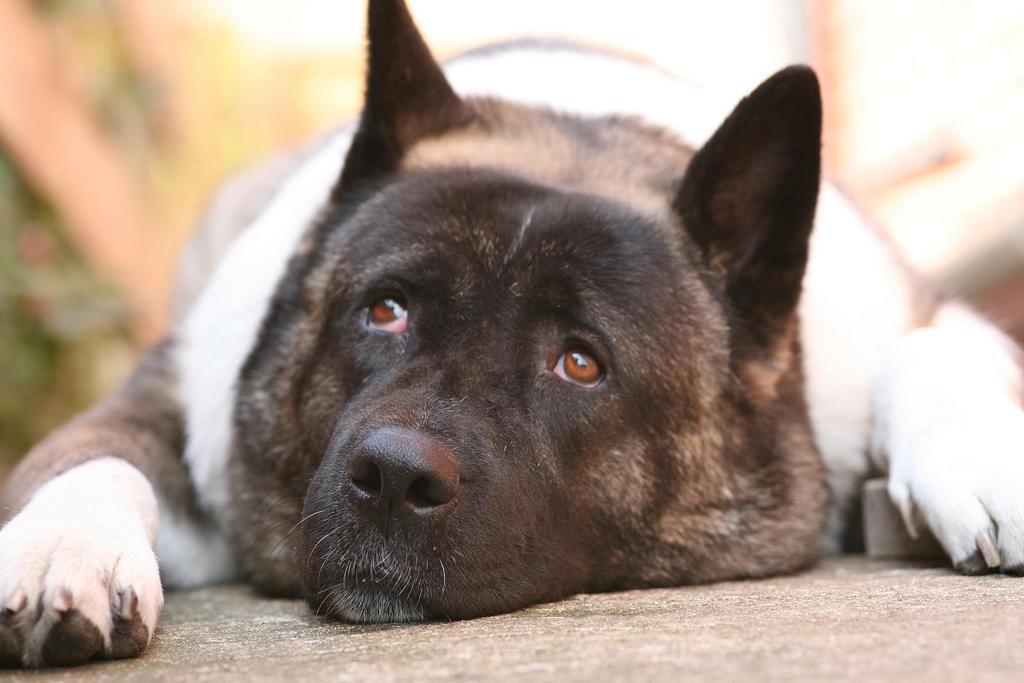In one or two sentences, can you explain what this image depicts? In the middle of this image, there is a dog in a black and white color combination, lying on the floor. And the background is blurred. 